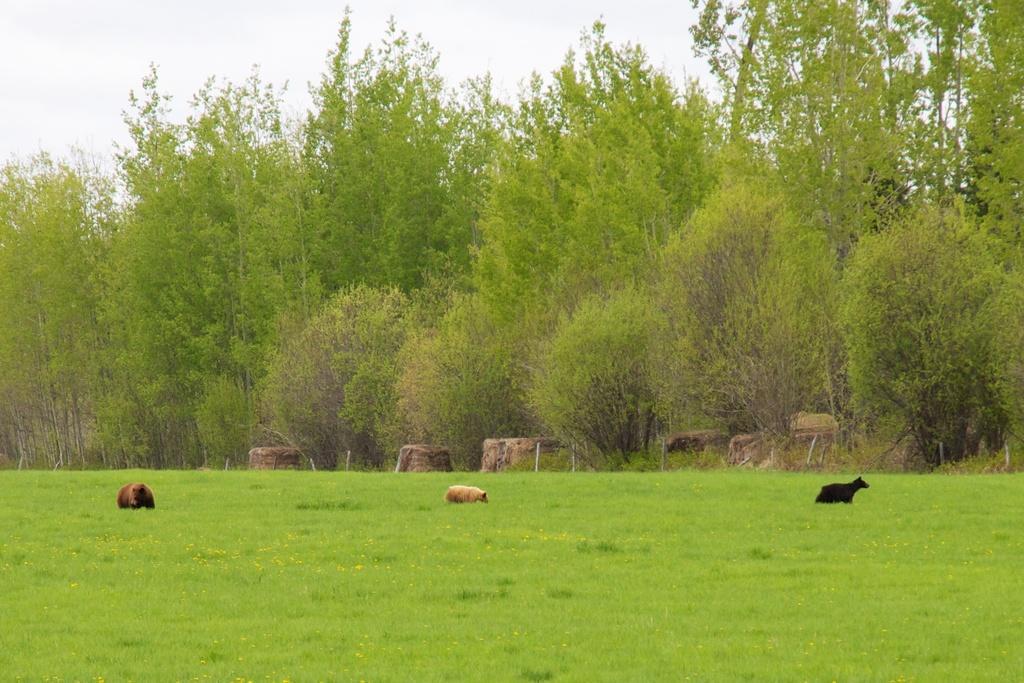How would you summarize this image in a sentence or two? In this picture we can see animals and grass. In the background we can see trees and the sky. 